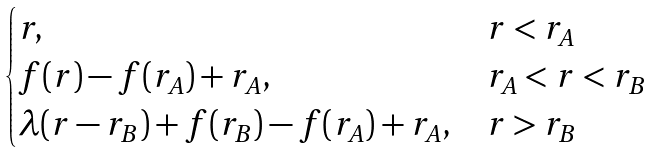Convert formula to latex. <formula><loc_0><loc_0><loc_500><loc_500>\begin{cases} r , & r < r _ { A } \\ f ( r ) - f ( r _ { A } ) + r _ { A } , & r _ { A } < r < r _ { B } \\ \lambda ( r - r _ { B } ) + f ( r _ { B } ) - f ( r _ { A } ) + r _ { A } , & r > r _ { B } \end{cases}</formula> 